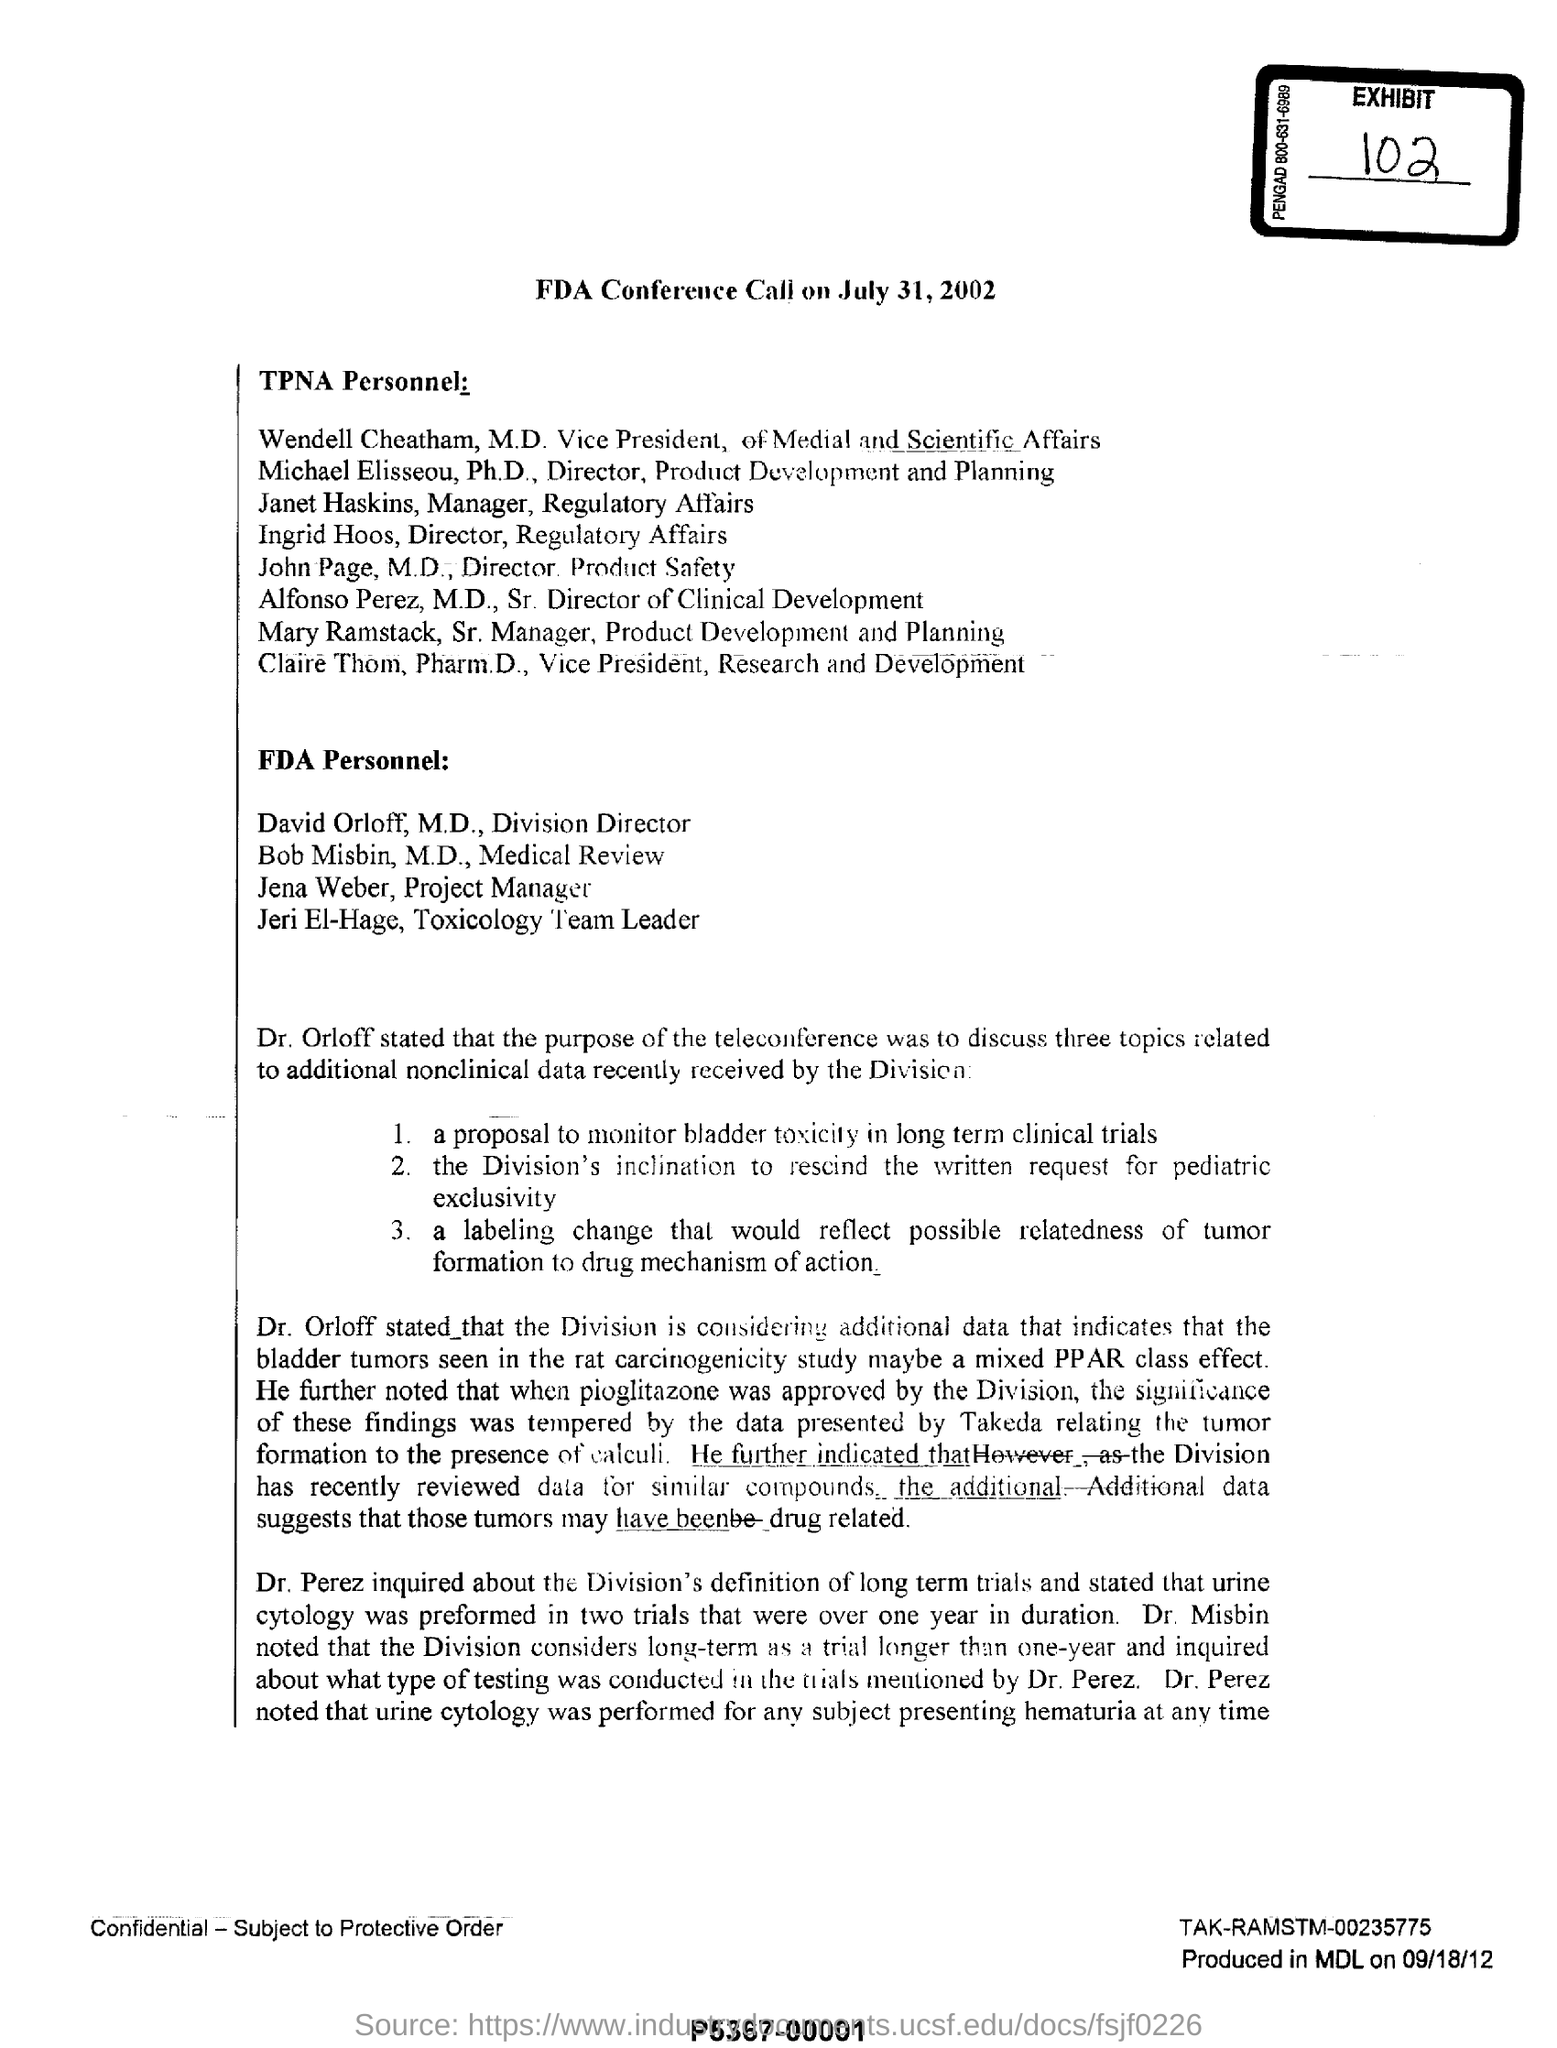When will the FDA Conference Call be held?
Provide a succinct answer. July 31, 2002. On the purpose of teleconference, how many topics were to be discussed?
Provide a succinct answer. 3 topics. What is the date mentioned at the bottom?
Your response must be concise. 09/18/12. 